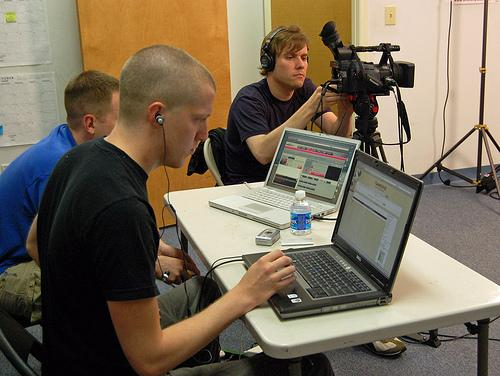Which one is doing silent work? Please explain your reasoning. middle. They are all working together and probably not being silent. 